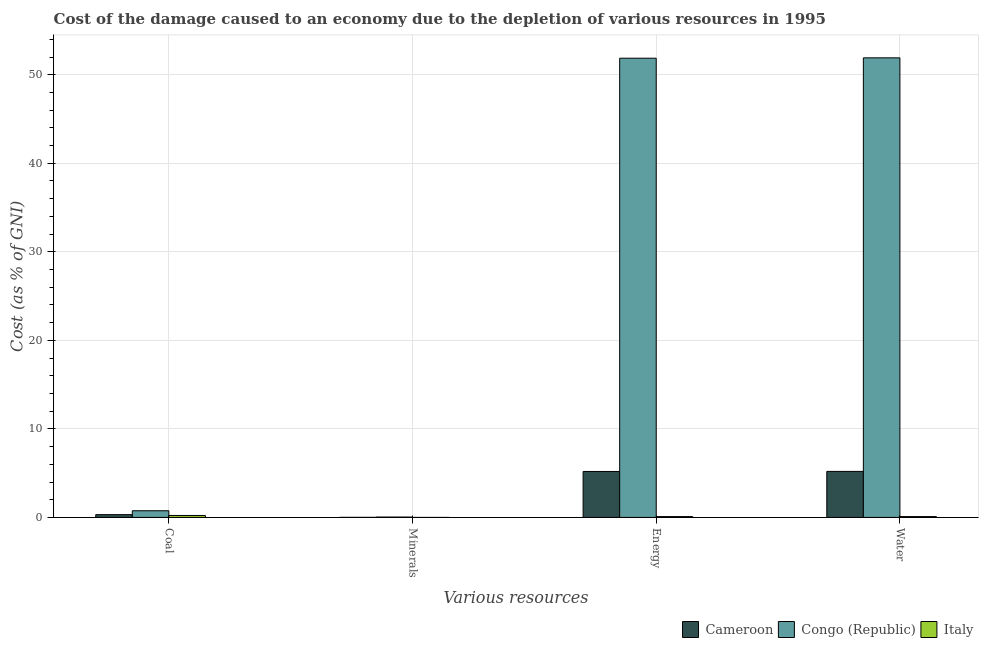How many groups of bars are there?
Ensure brevity in your answer.  4. How many bars are there on the 4th tick from the left?
Make the answer very short. 3. How many bars are there on the 1st tick from the right?
Provide a succinct answer. 3. What is the label of the 1st group of bars from the left?
Offer a very short reply. Coal. What is the cost of damage due to depletion of energy in Cameroon?
Your answer should be compact. 5.19. Across all countries, what is the maximum cost of damage due to depletion of minerals?
Provide a short and direct response. 0.04. Across all countries, what is the minimum cost of damage due to depletion of water?
Offer a very short reply. 0.09. In which country was the cost of damage due to depletion of energy maximum?
Offer a very short reply. Congo (Republic). What is the total cost of damage due to depletion of minerals in the graph?
Your answer should be very brief. 0.05. What is the difference between the cost of damage due to depletion of minerals in Congo (Republic) and that in Italy?
Keep it short and to the point. 0.04. What is the difference between the cost of damage due to depletion of coal in Italy and the cost of damage due to depletion of water in Congo (Republic)?
Make the answer very short. -51.69. What is the average cost of damage due to depletion of water per country?
Make the answer very short. 19.07. What is the difference between the cost of damage due to depletion of coal and cost of damage due to depletion of energy in Cameroon?
Your answer should be compact. -4.88. What is the ratio of the cost of damage due to depletion of water in Cameroon to that in Italy?
Your response must be concise. 54.85. Is the difference between the cost of damage due to depletion of energy in Italy and Cameroon greater than the difference between the cost of damage due to depletion of minerals in Italy and Cameroon?
Offer a terse response. No. What is the difference between the highest and the second highest cost of damage due to depletion of water?
Make the answer very short. 46.71. What is the difference between the highest and the lowest cost of damage due to depletion of minerals?
Your answer should be very brief. 0.04. Is the sum of the cost of damage due to depletion of coal in Congo (Republic) and Italy greater than the maximum cost of damage due to depletion of energy across all countries?
Make the answer very short. No. Is it the case that in every country, the sum of the cost of damage due to depletion of minerals and cost of damage due to depletion of energy is greater than the sum of cost of damage due to depletion of water and cost of damage due to depletion of coal?
Your answer should be compact. Yes. What does the 1st bar from the left in Coal represents?
Ensure brevity in your answer.  Cameroon. What does the 2nd bar from the right in Minerals represents?
Offer a very short reply. Congo (Republic). Is it the case that in every country, the sum of the cost of damage due to depletion of coal and cost of damage due to depletion of minerals is greater than the cost of damage due to depletion of energy?
Provide a succinct answer. No. Does the graph contain any zero values?
Give a very brief answer. No. How are the legend labels stacked?
Your answer should be compact. Horizontal. What is the title of the graph?
Ensure brevity in your answer.  Cost of the damage caused to an economy due to the depletion of various resources in 1995 . What is the label or title of the X-axis?
Give a very brief answer. Various resources. What is the label or title of the Y-axis?
Provide a succinct answer. Cost (as % of GNI). What is the Cost (as % of GNI) in Cameroon in Coal?
Make the answer very short. 0.31. What is the Cost (as % of GNI) in Congo (Republic) in Coal?
Keep it short and to the point. 0.75. What is the Cost (as % of GNI) of Italy in Coal?
Your response must be concise. 0.22. What is the Cost (as % of GNI) in Cameroon in Minerals?
Ensure brevity in your answer.  0.01. What is the Cost (as % of GNI) in Congo (Republic) in Minerals?
Give a very brief answer. 0.04. What is the Cost (as % of GNI) of Italy in Minerals?
Give a very brief answer. 1.19178546126206e-6. What is the Cost (as % of GNI) in Cameroon in Energy?
Provide a short and direct response. 5.19. What is the Cost (as % of GNI) of Congo (Republic) in Energy?
Make the answer very short. 51.87. What is the Cost (as % of GNI) of Italy in Energy?
Offer a terse response. 0.09. What is the Cost (as % of GNI) of Cameroon in Water?
Make the answer very short. 5.2. What is the Cost (as % of GNI) in Congo (Republic) in Water?
Your answer should be compact. 51.91. What is the Cost (as % of GNI) of Italy in Water?
Ensure brevity in your answer.  0.09. Across all Various resources, what is the maximum Cost (as % of GNI) in Cameroon?
Give a very brief answer. 5.2. Across all Various resources, what is the maximum Cost (as % of GNI) in Congo (Republic)?
Provide a succinct answer. 51.91. Across all Various resources, what is the maximum Cost (as % of GNI) in Italy?
Offer a terse response. 0.22. Across all Various resources, what is the minimum Cost (as % of GNI) in Cameroon?
Your answer should be compact. 0.01. Across all Various resources, what is the minimum Cost (as % of GNI) of Congo (Republic)?
Ensure brevity in your answer.  0.04. Across all Various resources, what is the minimum Cost (as % of GNI) of Italy?
Keep it short and to the point. 1.19178546126206e-6. What is the total Cost (as % of GNI) in Cameroon in the graph?
Your answer should be very brief. 10.71. What is the total Cost (as % of GNI) in Congo (Republic) in the graph?
Keep it short and to the point. 104.57. What is the total Cost (as % of GNI) of Italy in the graph?
Your answer should be very brief. 0.41. What is the difference between the Cost (as % of GNI) of Cameroon in Coal and that in Minerals?
Make the answer very short. 0.31. What is the difference between the Cost (as % of GNI) of Congo (Republic) in Coal and that in Minerals?
Your answer should be compact. 0.71. What is the difference between the Cost (as % of GNI) of Italy in Coal and that in Minerals?
Give a very brief answer. 0.22. What is the difference between the Cost (as % of GNI) of Cameroon in Coal and that in Energy?
Your response must be concise. -4.88. What is the difference between the Cost (as % of GNI) in Congo (Republic) in Coal and that in Energy?
Offer a terse response. -51.12. What is the difference between the Cost (as % of GNI) of Italy in Coal and that in Energy?
Provide a succinct answer. 0.13. What is the difference between the Cost (as % of GNI) of Cameroon in Coal and that in Water?
Give a very brief answer. -4.88. What is the difference between the Cost (as % of GNI) in Congo (Republic) in Coal and that in Water?
Give a very brief answer. -51.16. What is the difference between the Cost (as % of GNI) in Italy in Coal and that in Water?
Your answer should be compact. 0.13. What is the difference between the Cost (as % of GNI) of Cameroon in Minerals and that in Energy?
Provide a short and direct response. -5.18. What is the difference between the Cost (as % of GNI) in Congo (Republic) in Minerals and that in Energy?
Give a very brief answer. -51.83. What is the difference between the Cost (as % of GNI) of Italy in Minerals and that in Energy?
Offer a very short reply. -0.09. What is the difference between the Cost (as % of GNI) of Cameroon in Minerals and that in Water?
Ensure brevity in your answer.  -5.19. What is the difference between the Cost (as % of GNI) in Congo (Republic) in Minerals and that in Water?
Your response must be concise. -51.87. What is the difference between the Cost (as % of GNI) in Italy in Minerals and that in Water?
Keep it short and to the point. -0.09. What is the difference between the Cost (as % of GNI) in Cameroon in Energy and that in Water?
Provide a short and direct response. -0.01. What is the difference between the Cost (as % of GNI) of Congo (Republic) in Energy and that in Water?
Ensure brevity in your answer.  -0.04. What is the difference between the Cost (as % of GNI) of Italy in Energy and that in Water?
Make the answer very short. -0. What is the difference between the Cost (as % of GNI) of Cameroon in Coal and the Cost (as % of GNI) of Congo (Republic) in Minerals?
Ensure brevity in your answer.  0.27. What is the difference between the Cost (as % of GNI) of Cameroon in Coal and the Cost (as % of GNI) of Italy in Minerals?
Make the answer very short. 0.31. What is the difference between the Cost (as % of GNI) in Congo (Republic) in Coal and the Cost (as % of GNI) in Italy in Minerals?
Provide a short and direct response. 0.75. What is the difference between the Cost (as % of GNI) in Cameroon in Coal and the Cost (as % of GNI) in Congo (Republic) in Energy?
Keep it short and to the point. -51.55. What is the difference between the Cost (as % of GNI) in Cameroon in Coal and the Cost (as % of GNI) in Italy in Energy?
Offer a terse response. 0.22. What is the difference between the Cost (as % of GNI) in Congo (Republic) in Coal and the Cost (as % of GNI) in Italy in Energy?
Provide a succinct answer. 0.66. What is the difference between the Cost (as % of GNI) of Cameroon in Coal and the Cost (as % of GNI) of Congo (Republic) in Water?
Provide a short and direct response. -51.59. What is the difference between the Cost (as % of GNI) in Cameroon in Coal and the Cost (as % of GNI) in Italy in Water?
Give a very brief answer. 0.22. What is the difference between the Cost (as % of GNI) of Congo (Republic) in Coal and the Cost (as % of GNI) of Italy in Water?
Give a very brief answer. 0.66. What is the difference between the Cost (as % of GNI) of Cameroon in Minerals and the Cost (as % of GNI) of Congo (Republic) in Energy?
Your answer should be compact. -51.86. What is the difference between the Cost (as % of GNI) in Cameroon in Minerals and the Cost (as % of GNI) in Italy in Energy?
Make the answer very short. -0.09. What is the difference between the Cost (as % of GNI) of Congo (Republic) in Minerals and the Cost (as % of GNI) of Italy in Energy?
Offer a very short reply. -0.06. What is the difference between the Cost (as % of GNI) in Cameroon in Minerals and the Cost (as % of GNI) in Congo (Republic) in Water?
Ensure brevity in your answer.  -51.9. What is the difference between the Cost (as % of GNI) of Cameroon in Minerals and the Cost (as % of GNI) of Italy in Water?
Provide a short and direct response. -0.09. What is the difference between the Cost (as % of GNI) in Congo (Republic) in Minerals and the Cost (as % of GNI) in Italy in Water?
Ensure brevity in your answer.  -0.06. What is the difference between the Cost (as % of GNI) in Cameroon in Energy and the Cost (as % of GNI) in Congo (Republic) in Water?
Give a very brief answer. -46.72. What is the difference between the Cost (as % of GNI) in Cameroon in Energy and the Cost (as % of GNI) in Italy in Water?
Ensure brevity in your answer.  5.1. What is the difference between the Cost (as % of GNI) in Congo (Republic) in Energy and the Cost (as % of GNI) in Italy in Water?
Provide a short and direct response. 51.77. What is the average Cost (as % of GNI) of Cameroon per Various resources?
Your answer should be compact. 2.68. What is the average Cost (as % of GNI) of Congo (Republic) per Various resources?
Your answer should be compact. 26.14. What is the average Cost (as % of GNI) in Italy per Various resources?
Provide a short and direct response. 0.1. What is the difference between the Cost (as % of GNI) of Cameroon and Cost (as % of GNI) of Congo (Republic) in Coal?
Your response must be concise. -0.44. What is the difference between the Cost (as % of GNI) of Cameroon and Cost (as % of GNI) of Italy in Coal?
Offer a terse response. 0.09. What is the difference between the Cost (as % of GNI) in Congo (Republic) and Cost (as % of GNI) in Italy in Coal?
Provide a short and direct response. 0.53. What is the difference between the Cost (as % of GNI) of Cameroon and Cost (as % of GNI) of Congo (Republic) in Minerals?
Offer a very short reply. -0.03. What is the difference between the Cost (as % of GNI) of Cameroon and Cost (as % of GNI) of Italy in Minerals?
Give a very brief answer. 0.01. What is the difference between the Cost (as % of GNI) in Congo (Republic) and Cost (as % of GNI) in Italy in Minerals?
Keep it short and to the point. 0.04. What is the difference between the Cost (as % of GNI) of Cameroon and Cost (as % of GNI) of Congo (Republic) in Energy?
Make the answer very short. -46.68. What is the difference between the Cost (as % of GNI) of Cameroon and Cost (as % of GNI) of Italy in Energy?
Your answer should be compact. 5.1. What is the difference between the Cost (as % of GNI) of Congo (Republic) and Cost (as % of GNI) of Italy in Energy?
Keep it short and to the point. 51.77. What is the difference between the Cost (as % of GNI) of Cameroon and Cost (as % of GNI) of Congo (Republic) in Water?
Give a very brief answer. -46.71. What is the difference between the Cost (as % of GNI) of Cameroon and Cost (as % of GNI) of Italy in Water?
Ensure brevity in your answer.  5.1. What is the difference between the Cost (as % of GNI) of Congo (Republic) and Cost (as % of GNI) of Italy in Water?
Your answer should be very brief. 51.81. What is the ratio of the Cost (as % of GNI) of Cameroon in Coal to that in Minerals?
Your answer should be very brief. 39.63. What is the ratio of the Cost (as % of GNI) in Congo (Republic) in Coal to that in Minerals?
Offer a very short reply. 18.96. What is the ratio of the Cost (as % of GNI) of Italy in Coal to that in Minerals?
Keep it short and to the point. 1.84e+05. What is the ratio of the Cost (as % of GNI) in Cameroon in Coal to that in Energy?
Provide a succinct answer. 0.06. What is the ratio of the Cost (as % of GNI) in Congo (Republic) in Coal to that in Energy?
Give a very brief answer. 0.01. What is the ratio of the Cost (as % of GNI) of Italy in Coal to that in Energy?
Your answer should be compact. 2.32. What is the ratio of the Cost (as % of GNI) in Cameroon in Coal to that in Water?
Offer a very short reply. 0.06. What is the ratio of the Cost (as % of GNI) of Congo (Republic) in Coal to that in Water?
Make the answer very short. 0.01. What is the ratio of the Cost (as % of GNI) in Italy in Coal to that in Water?
Your answer should be very brief. 2.32. What is the ratio of the Cost (as % of GNI) in Cameroon in Minerals to that in Energy?
Keep it short and to the point. 0. What is the ratio of the Cost (as % of GNI) of Congo (Republic) in Minerals to that in Energy?
Ensure brevity in your answer.  0. What is the ratio of the Cost (as % of GNI) of Cameroon in Minerals to that in Water?
Your answer should be compact. 0. What is the ratio of the Cost (as % of GNI) of Congo (Republic) in Minerals to that in Water?
Keep it short and to the point. 0. What is the ratio of the Cost (as % of GNI) in Italy in Energy to that in Water?
Keep it short and to the point. 1. What is the difference between the highest and the second highest Cost (as % of GNI) of Cameroon?
Your response must be concise. 0.01. What is the difference between the highest and the second highest Cost (as % of GNI) in Congo (Republic)?
Provide a short and direct response. 0.04. What is the difference between the highest and the second highest Cost (as % of GNI) in Italy?
Give a very brief answer. 0.13. What is the difference between the highest and the lowest Cost (as % of GNI) in Cameroon?
Provide a short and direct response. 5.19. What is the difference between the highest and the lowest Cost (as % of GNI) in Congo (Republic)?
Give a very brief answer. 51.87. What is the difference between the highest and the lowest Cost (as % of GNI) in Italy?
Offer a terse response. 0.22. 